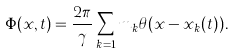Convert formula to latex. <formula><loc_0><loc_0><loc_500><loc_500>\Phi ( x , t ) = \frac { 2 \pi } { \gamma } \sum _ { k = 1 } m _ { k } \theta ( x - x _ { k } ( t ) ) .</formula> 